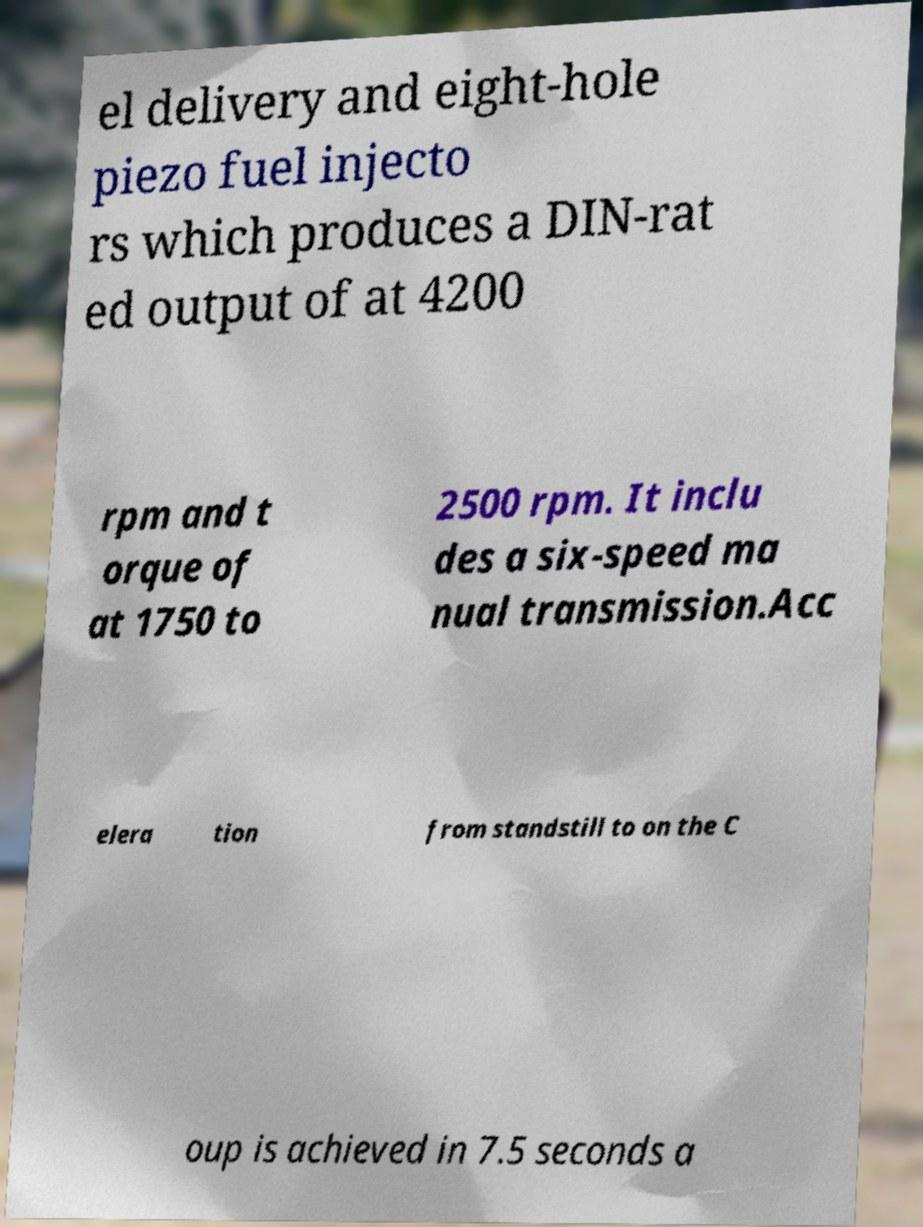Can you accurately transcribe the text from the provided image for me? el delivery and eight-hole piezo fuel injecto rs which produces a DIN-rat ed output of at 4200 rpm and t orque of at 1750 to 2500 rpm. It inclu des a six-speed ma nual transmission.Acc elera tion from standstill to on the C oup is achieved in 7.5 seconds a 